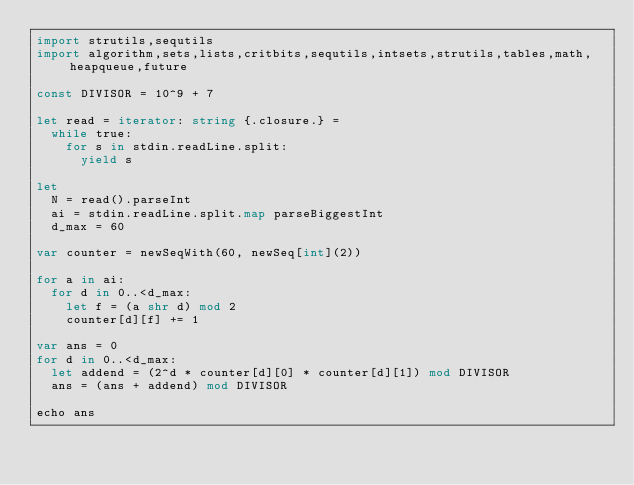<code> <loc_0><loc_0><loc_500><loc_500><_Nim_>import strutils,sequtils
import algorithm,sets,lists,critbits,sequtils,intsets,strutils,tables,math,heapqueue,future

const DIVISOR = 10^9 + 7

let read = iterator: string {.closure.} =
  while true:
    for s in stdin.readLine.split:
      yield s

let
  N = read().parseInt
  ai = stdin.readLine.split.map parseBiggestInt
  d_max = 60

var counter = newSeqWith(60, newSeq[int](2))

for a in ai:
  for d in 0..<d_max:
    let f = (a shr d) mod 2
    counter[d][f] += 1

var ans = 0
for d in 0..<d_max:
  let addend = (2^d * counter[d][0] * counter[d][1]) mod DIVISOR
  ans = (ans + addend) mod DIVISOR

echo ans
</code> 